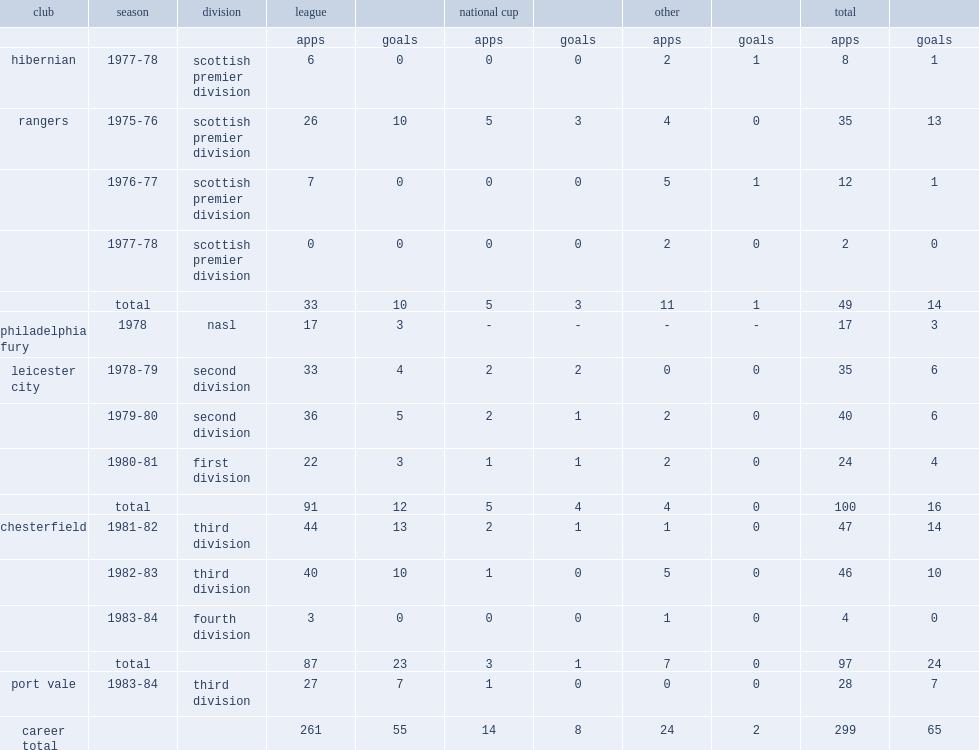I'm looking to parse the entire table for insights. Could you assist me with that? {'header': ['club', 'season', 'division', 'league', '', 'national cup', '', 'other', '', 'total', ''], 'rows': [['', '', '', 'apps', 'goals', 'apps', 'goals', 'apps', 'goals', 'apps', 'goals'], ['hibernian', '1977-78', 'scottish premier division', '6', '0', '0', '0', '2', '1', '8', '1'], ['rangers', '1975-76', 'scottish premier division', '26', '10', '5', '3', '4', '0', '35', '13'], ['', '1976-77', 'scottish premier division', '7', '0', '0', '0', '5', '1', '12', '1'], ['', '1977-78', 'scottish premier division', '0', '0', '0', '0', '2', '0', '2', '0'], ['', 'total', '', '33', '10', '5', '3', '11', '1', '49', '14'], ['philadelphia fury', '1978', 'nasl', '17', '3', '-', '-', '-', '-', '17', '3'], ['leicester city', '1978-79', 'second division', '33', '4', '2', '2', '0', '0', '35', '6'], ['', '1979-80', 'second division', '36', '5', '2', '1', '2', '0', '40', '6'], ['', '1980-81', 'first division', '22', '3', '1', '1', '2', '0', '24', '4'], ['', 'total', '', '91', '12', '5', '4', '4', '0', '100', '16'], ['chesterfield', '1981-82', 'third division', '44', '13', '2', '1', '1', '0', '47', '14'], ['', '1982-83', 'third division', '40', '10', '1', '0', '5', '0', '46', '10'], ['', '1983-84', 'fourth division', '3', '0', '0', '0', '1', '0', '4', '0'], ['', 'total', '', '87', '23', '3', '1', '7', '0', '97', '24'], ['port vale', '1983-84', 'third division', '27', '7', '1', '0', '0', '0', '28', '7'], ['career total', '', '', '261', '55', '14', '8', '24', '2', '299', '65']]} Which division did henderson move to chesterfield in 1981-82. Third division. 